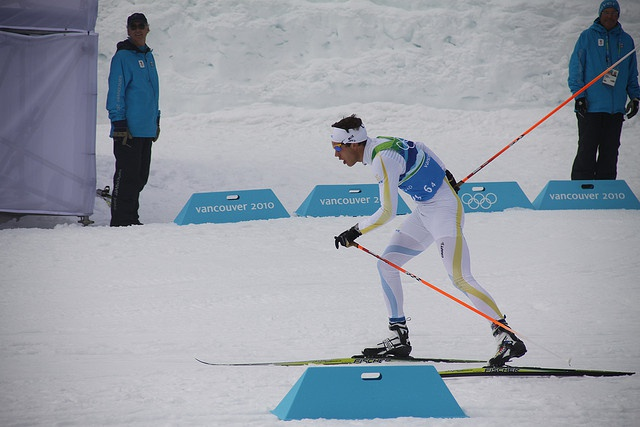Describe the objects in this image and their specific colors. I can see people in black, darkgray, and blue tones, people in black, darkblue, blue, and gray tones, people in black, blue, navy, and gray tones, and skis in black, darkgray, lightgray, and gray tones in this image. 